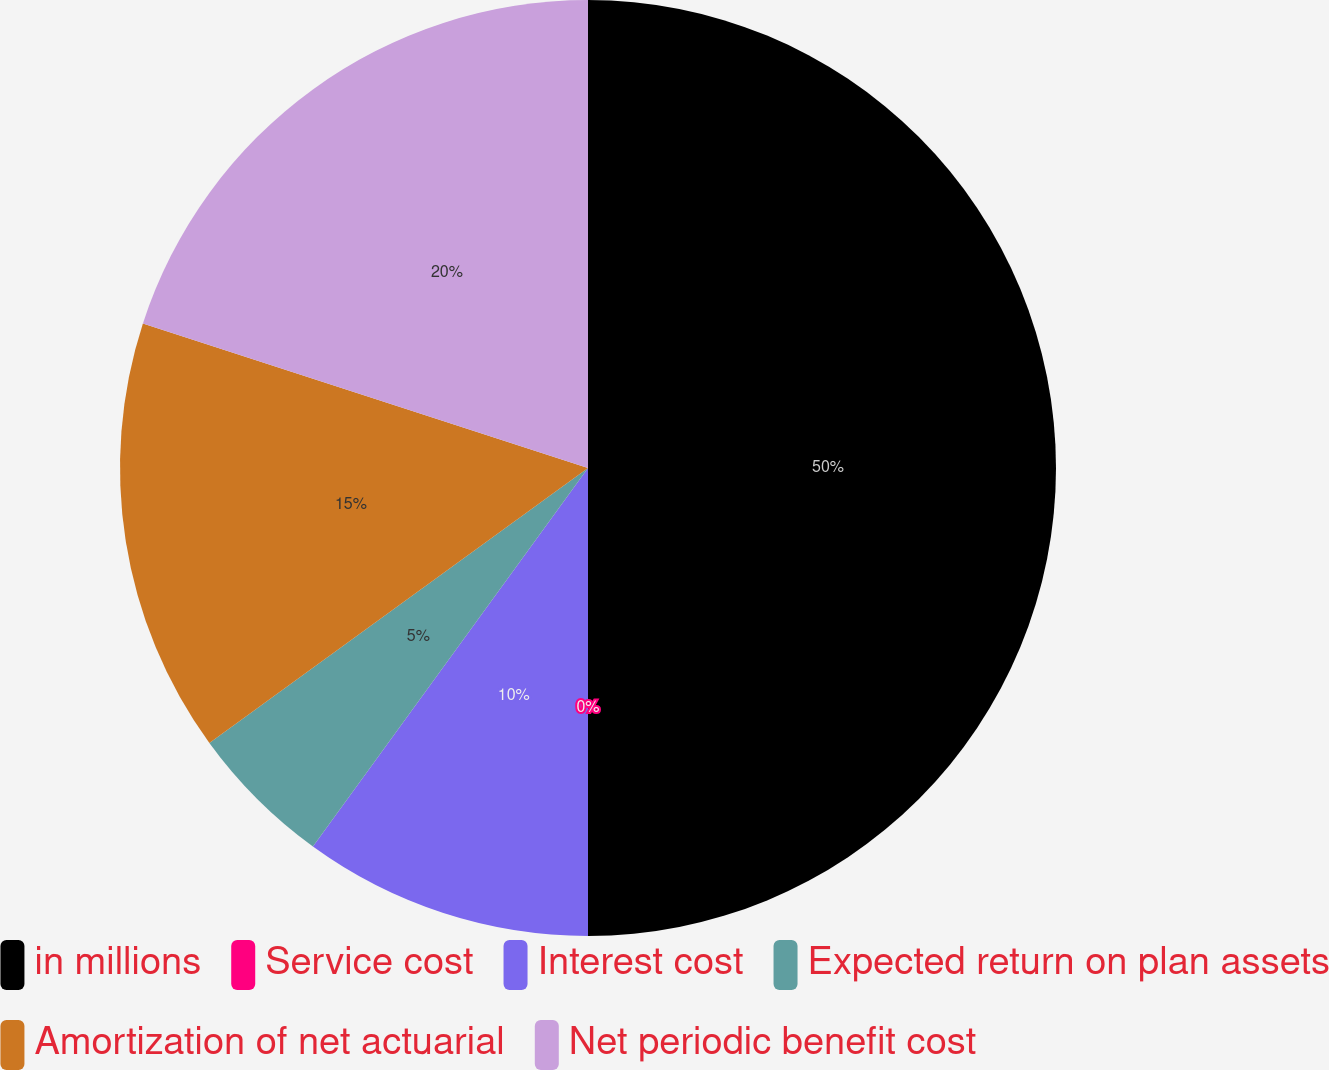<chart> <loc_0><loc_0><loc_500><loc_500><pie_chart><fcel>in millions<fcel>Service cost<fcel>Interest cost<fcel>Expected return on plan assets<fcel>Amortization of net actuarial<fcel>Net periodic benefit cost<nl><fcel>50.0%<fcel>0.0%<fcel>10.0%<fcel>5.0%<fcel>15.0%<fcel>20.0%<nl></chart> 